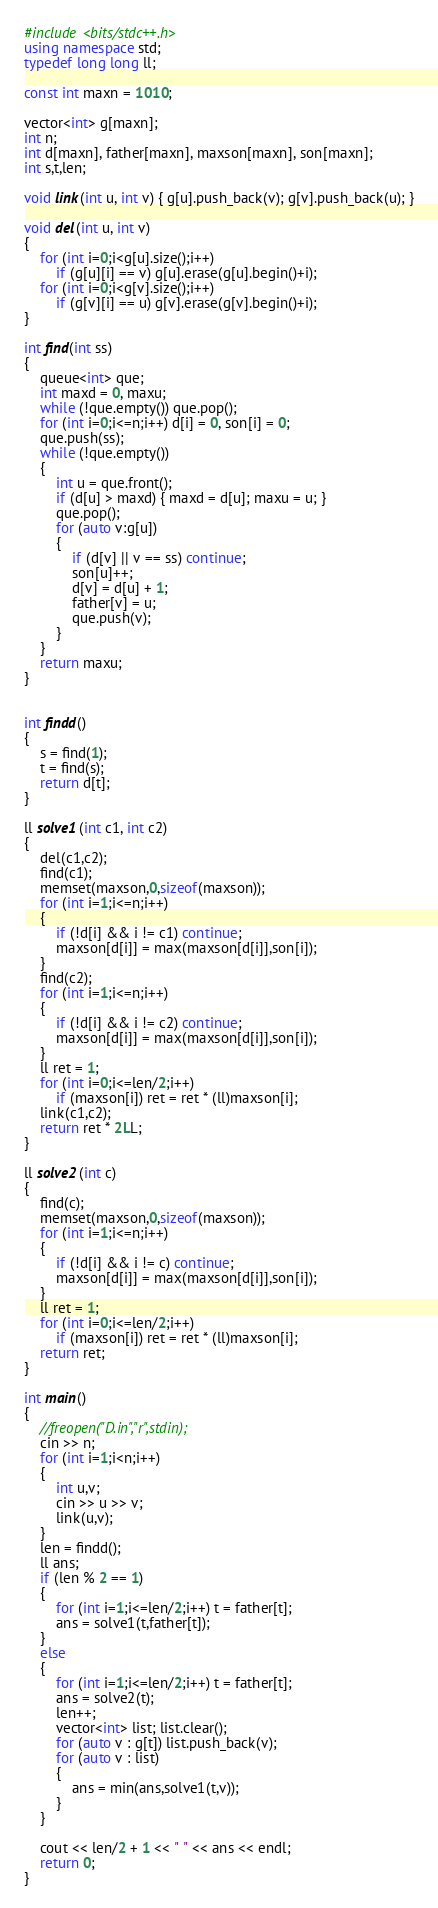<code> <loc_0><loc_0><loc_500><loc_500><_C++_>#include <bits/stdc++.h>
using namespace std;
typedef long long ll;

const int maxn = 1010;

vector<int> g[maxn];
int n;
int d[maxn], father[maxn], maxson[maxn], son[maxn];
int s,t,len;

void link(int u, int v) { g[u].push_back(v); g[v].push_back(u); }

void del(int u, int v)
{
	for (int i=0;i<g[u].size();i++)
		if (g[u][i] == v) g[u].erase(g[u].begin()+i);
	for (int i=0;i<g[v].size();i++)
		if (g[v][i] == u) g[v].erase(g[v].begin()+i);
}

int find(int ss)
{
	queue<int> que;
	int maxd = 0, maxu;
	while (!que.empty()) que.pop();
	for (int i=0;i<=n;i++) d[i] = 0, son[i] = 0;
	que.push(ss);
	while (!que.empty())
	{
		int u = que.front();
		if (d[u] > maxd) { maxd = d[u]; maxu = u; }
		que.pop();
		for (auto v:g[u])
		{
			if (d[v] || v == ss) continue;
			son[u]++;
			d[v] = d[u] + 1;
			father[v] = u;
			que.push(v);
		}
	}
	return maxu;
}


int findd()
{
	s = find(1);
	t = find(s);
	return d[t];
}

ll solve1(int c1, int c2)
{
	del(c1,c2);
	find(c1);
	memset(maxson,0,sizeof(maxson));
	for (int i=1;i<=n;i++)
	{
		if (!d[i] && i != c1) continue;
		maxson[d[i]] = max(maxson[d[i]],son[i]);
	}
	find(c2);
	for (int i=1;i<=n;i++)
	{
		if (!d[i] && i != c2) continue;
		maxson[d[i]] = max(maxson[d[i]],son[i]);
	}
	ll ret = 1;
	for (int i=0;i<=len/2;i++)
		if (maxson[i]) ret = ret * (ll)maxson[i];
	link(c1,c2);
	return ret * 2LL;
}

ll solve2(int c)
{
	find(c);
	memset(maxson,0,sizeof(maxson));
	for (int i=1;i<=n;i++)
	{
		if (!d[i] && i != c) continue;
		maxson[d[i]] = max(maxson[d[i]],son[i]);
	}
	ll ret = 1;
	for (int i=0;i<=len/2;i++) 
		if (maxson[i]) ret = ret * (ll)maxson[i];
	return ret;
}

int main()
{
	//freopen("D.in","r",stdin);
	cin >> n;
	for (int i=1;i<n;i++)
	{
		int u,v;
		cin >> u >> v;
		link(u,v);
	}
	len = findd();
	ll ans;
	if (len % 2 == 1)
	{
		for (int i=1;i<=len/2;i++) t = father[t];
		ans = solve1(t,father[t]);
	}
	else
	{
		for (int i=1;i<=len/2;i++) t = father[t];
		ans = solve2(t);
		len++;
		vector<int> list; list.clear();
		for (auto v : g[t]) list.push_back(v);
		for (auto v : list)
		{
			ans = min(ans,solve1(t,v));
		}
	}

	cout << len/2 + 1 << " " << ans << endl;
	return 0;
}
</code> 